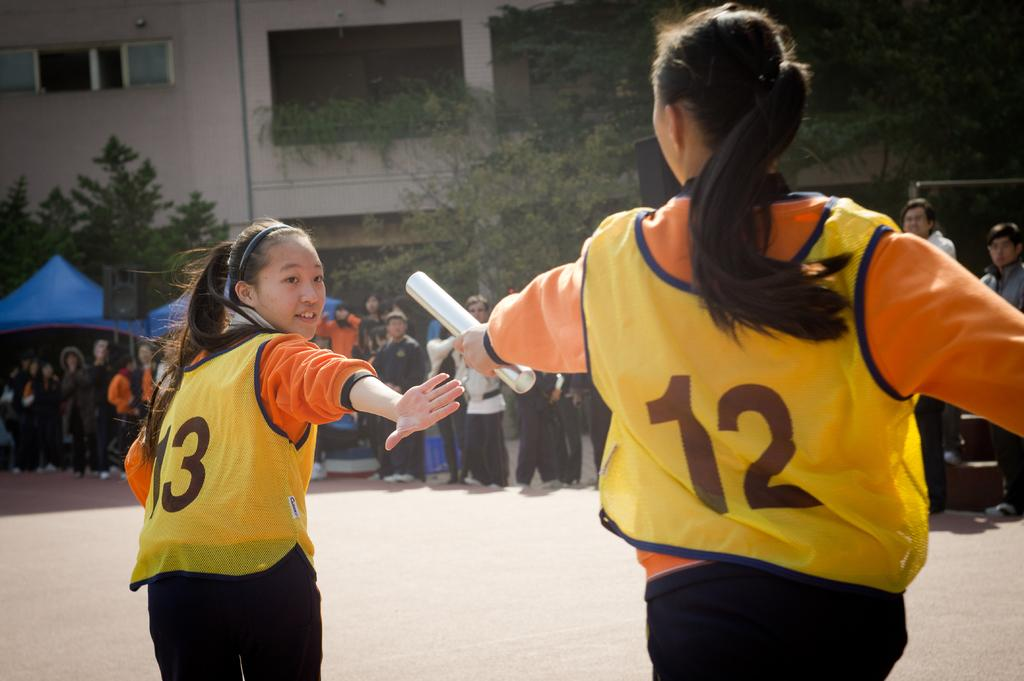<image>
Share a concise interpretation of the image provided. A girl wearing a number 12 jersey is passing a baton to a runner wearing a number 13. 